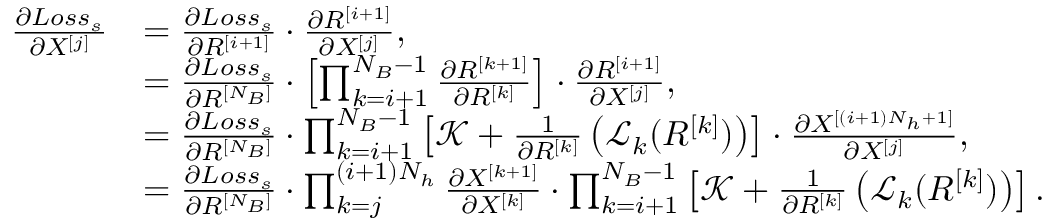Convert formula to latex. <formula><loc_0><loc_0><loc_500><loc_500>\begin{array} { r l } { \frac { \partial L o s s _ { s } } { \partial X ^ { [ j ] } } } & { = \frac { \partial L o s s _ { s } } { \partial R ^ { [ i + 1 ] } } \cdot \frac { \partial R ^ { [ i + 1 ] } } { \partial X ^ { [ j ] } } , } \\ & { = \frac { \partial L o s s _ { s } } { \partial R ^ { [ N _ { B } ] } } \cdot \left [ \prod _ { k = i + 1 } ^ { N _ { B } - 1 } \frac { \partial R ^ { [ k + 1 ] } } { \partial R ^ { [ k ] } } \right ] \cdot \frac { \partial R ^ { [ i + 1 ] } } { \partial X ^ { [ j ] } } , } \\ & { = \frac { \partial L o s s _ { s } } { \partial R ^ { [ N _ { B } ] } } \cdot \prod _ { k = i + 1 } ^ { N _ { B } - 1 } \left [ \mathcal { K } + \frac { 1 } { \partial R ^ { [ k ] } } \left ( \mathcal { L } _ { k } ( R ^ { [ k ] } ) \right ) \right ] \cdot \frac { \partial X ^ { [ ( i + 1 ) N _ { h } + 1 ] } } { \partial X ^ { [ j ] } } , } \\ & { = \frac { \partial L o s s _ { s } } { \partial R ^ { [ N _ { B } ] } } \cdot \prod _ { k = j } ^ { ( i + 1 ) N _ { h } } \frac { \partial X ^ { [ k + 1 ] } } { \partial X ^ { [ k ] } } \cdot \prod _ { k = i + 1 } ^ { N _ { B } - 1 } \left [ \mathcal { K } + \frac { 1 } { \partial R ^ { [ k ] } } \left ( \mathcal { L } _ { k } ( R ^ { [ k ] } ) \right ) \right ] . } \end{array}</formula> 